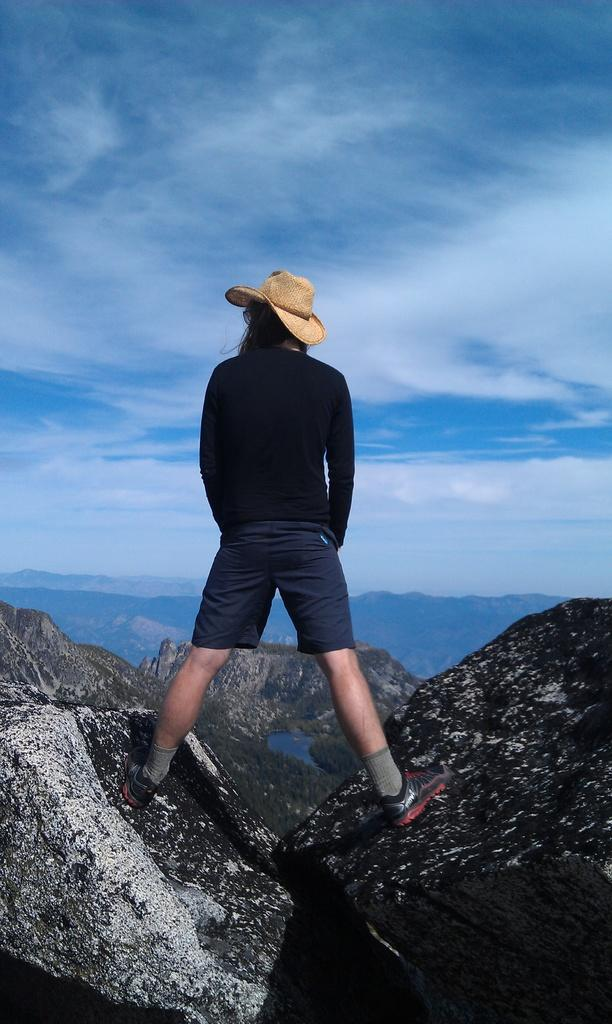Who or what is present in the image? There is a person in the image. What is the person wearing on their head? The person is wearing a hat. What type of landscape can be seen in the image? Hills and trees are visible in the image. What part of the natural environment is visible in the image? The sky is visible in the image. What type of toothpaste is the person using in the image? There is no toothpaste present in the image, as it features a person wearing a hat in a landscape with hills, trees, and the sky. 